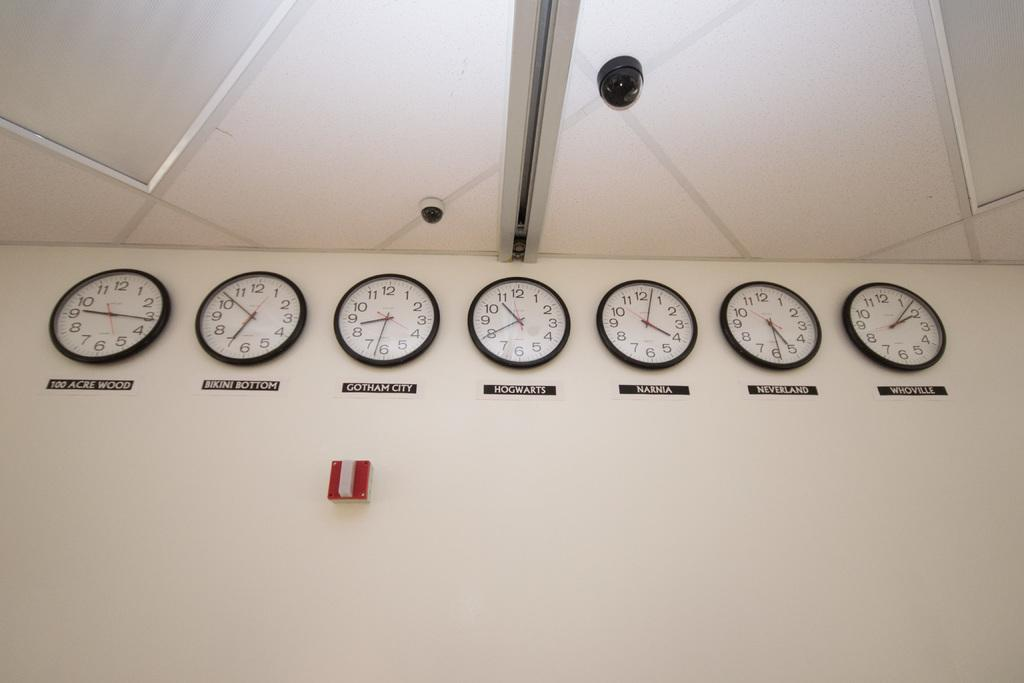<image>
Share a concise interpretation of the image provided. A row of seven clocks are on a wall under a security camera and under the first clock says 100 Acre Wood. 